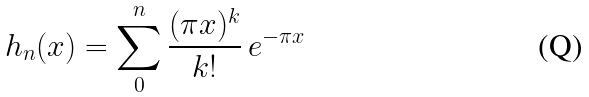Convert formula to latex. <formula><loc_0><loc_0><loc_500><loc_500>h _ { n } ( x ) = \sum _ { 0 } ^ { n } \frac { ( \pi x ) ^ { k } } { k ! } \, e ^ { - \pi x }</formula> 